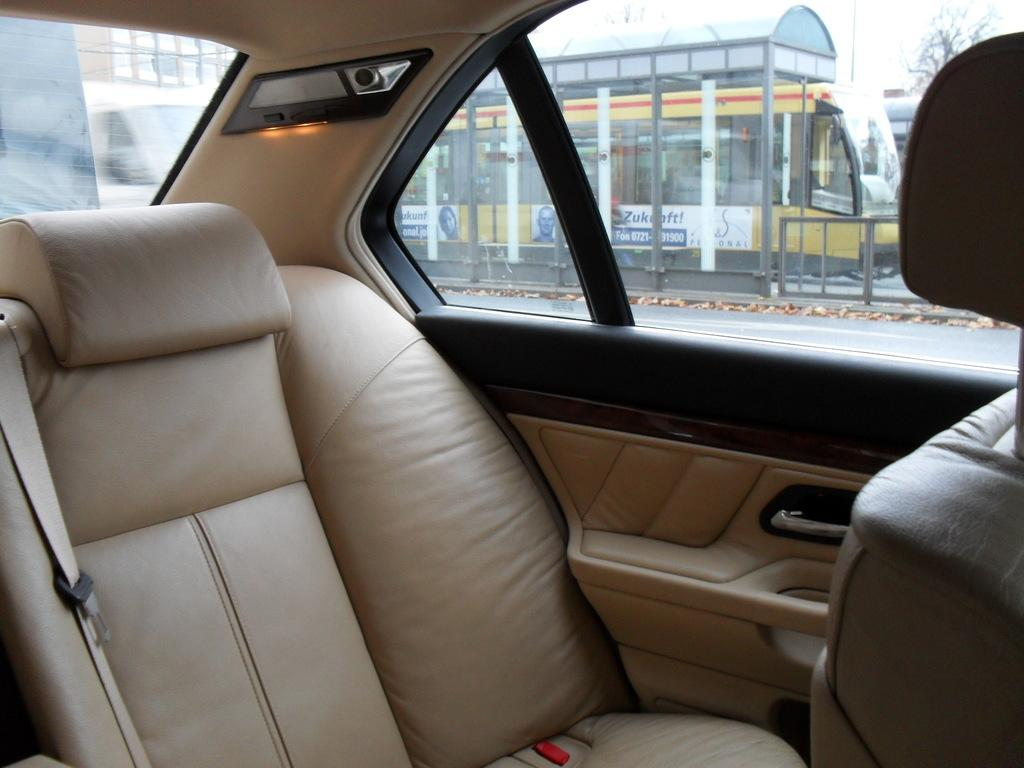What type of vehicle is the inside view of in the image? The image is an inside view of a car. What can be found inside the car? There is a seat in the car. What is one of the car's features visible in the image? There is a side door in the car. What allows light and visibility inside the car? There are glasses (windows) in the car. What can be seen through the glasses? Bidding (buildings), poles (likely streetlights or signposts), a bus stop, a bus, a bare tree, and the sky are visible through the glasses. What type of army is visible through the glasses in the image? There is no army visible through the glasses in the image. What level of difficulty is the lead character experiencing in the image? There is no lead character or any indication of difficulty in the image. 